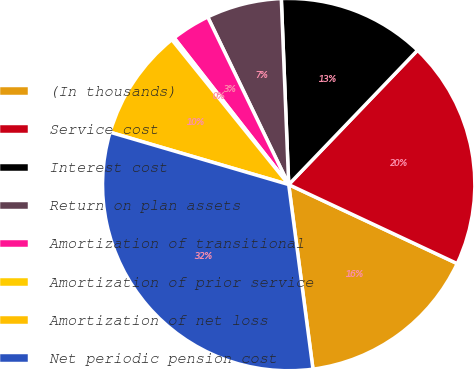<chart> <loc_0><loc_0><loc_500><loc_500><pie_chart><fcel>(In thousands)<fcel>Service cost<fcel>Interest cost<fcel>Return on plan assets<fcel>Amortization of transitional<fcel>Amortization of prior service<fcel>Amortization of net loss<fcel>Net periodic pension cost<nl><fcel>15.94%<fcel>19.81%<fcel>12.8%<fcel>6.53%<fcel>3.39%<fcel>0.25%<fcel>9.66%<fcel>31.62%<nl></chart> 